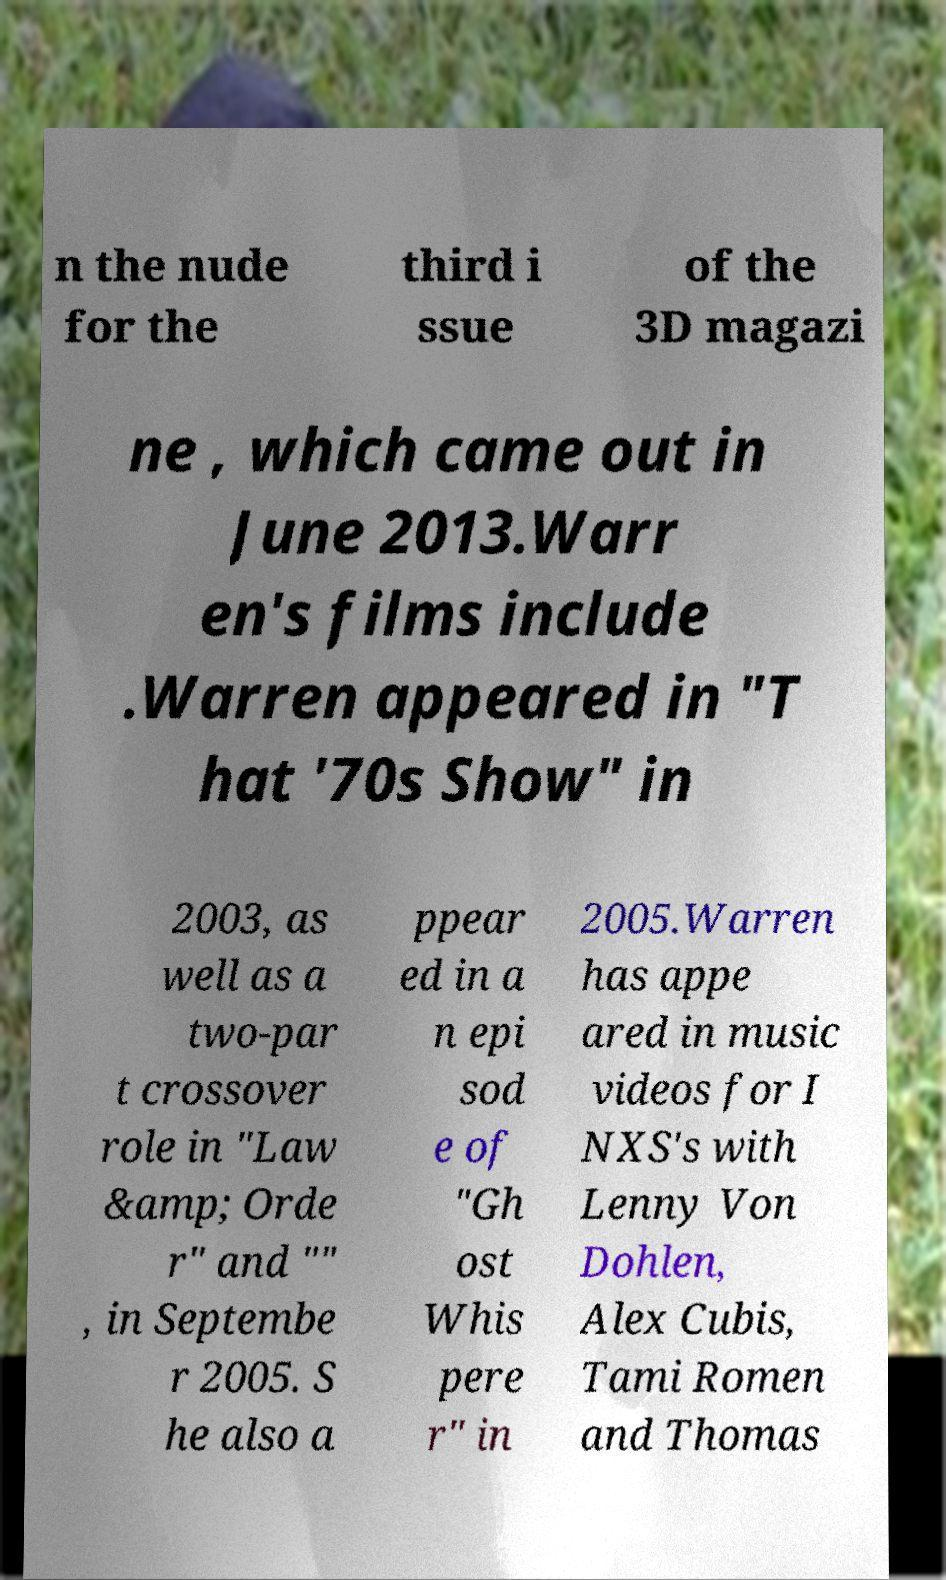What messages or text are displayed in this image? I need them in a readable, typed format. n the nude for the third i ssue of the 3D magazi ne , which came out in June 2013.Warr en's films include .Warren appeared in "T hat '70s Show" in 2003, as well as a two-par t crossover role in "Law &amp; Orde r" and "" , in Septembe r 2005. S he also a ppear ed in a n epi sod e of "Gh ost Whis pere r" in 2005.Warren has appe ared in music videos for I NXS's with Lenny Von Dohlen, Alex Cubis, Tami Romen and Thomas 